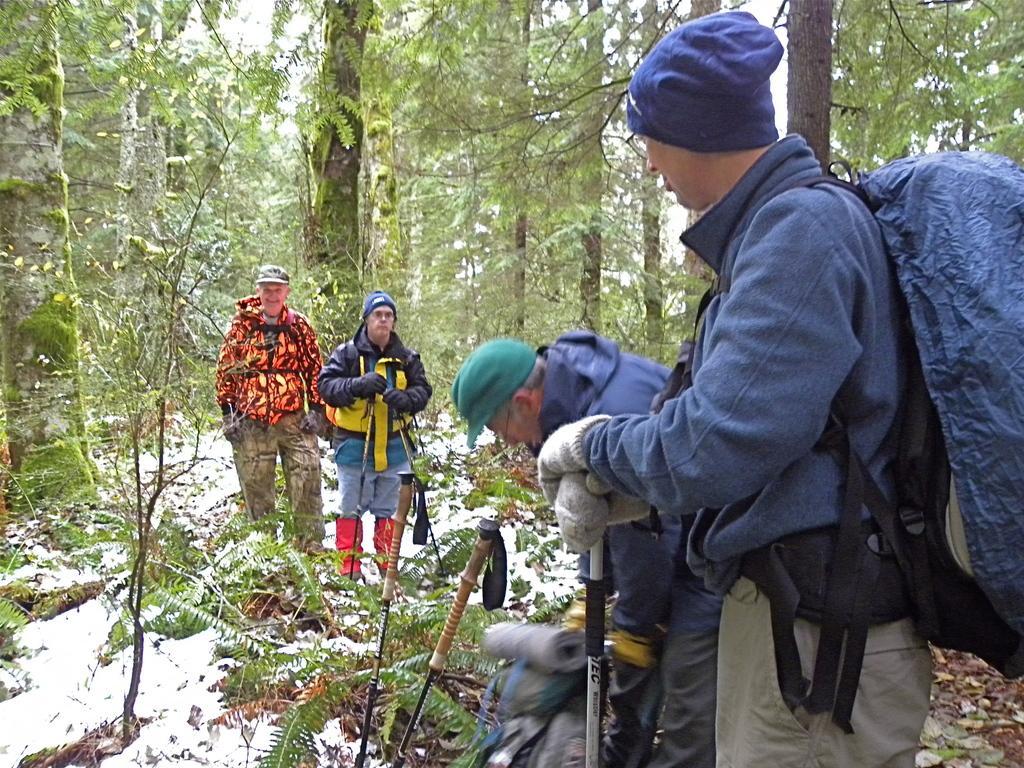Could you give a brief overview of what you see in this image? In this image in the foreground there are some people who are standing and some of them are holding some sticks, and they are wearing bags. In the background there are trees, at the bottom there is snow and some plants. 